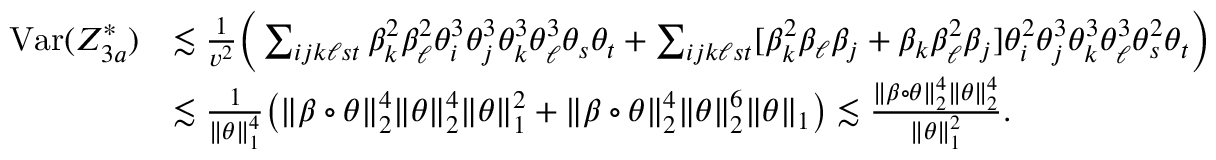<formula> <loc_0><loc_0><loc_500><loc_500>\begin{array} { r l } { V a r ( Z _ { 3 a } ^ { * } ) } & { \lesssim \frac { 1 } { v ^ { 2 } } \left ( \sum _ { i j k \ell s t } \beta _ { k } ^ { 2 } \beta _ { \ell } ^ { 2 } \theta _ { i } ^ { 3 } \theta _ { j } ^ { 3 } \theta _ { k } ^ { 3 } \theta _ { \ell } ^ { 3 } \theta _ { s } \theta _ { t } + \sum _ { i j k \ell s t } [ \beta _ { k } ^ { 2 } \beta _ { \ell } \beta _ { j } + \beta _ { k } \beta _ { \ell } ^ { 2 } \beta _ { j } ] \theta _ { i } ^ { 2 } \theta _ { j } ^ { 3 } \theta _ { k } ^ { 3 } \theta _ { \ell } ^ { 3 } \theta _ { s } ^ { 2 } \theta _ { t } \right ) } \\ & { \lesssim \frac { 1 } { \| \theta \| _ { 1 } ^ { 4 } } \left ( \| \beta \circ \theta \| _ { 2 } ^ { 4 } \| \theta \| _ { 2 } ^ { 4 } \| \theta \| _ { 1 } ^ { 2 } + \| \beta \circ \theta \| _ { 2 } ^ { 4 } \| \theta \| _ { 2 } ^ { 6 } \| \theta \| _ { 1 } \right ) \lesssim \frac { \| \beta \circ \theta \| _ { 2 } ^ { 4 } \| \theta \| _ { 2 } ^ { 4 } } { \| \theta \| _ { 1 } ^ { 2 } } . } \end{array}</formula> 